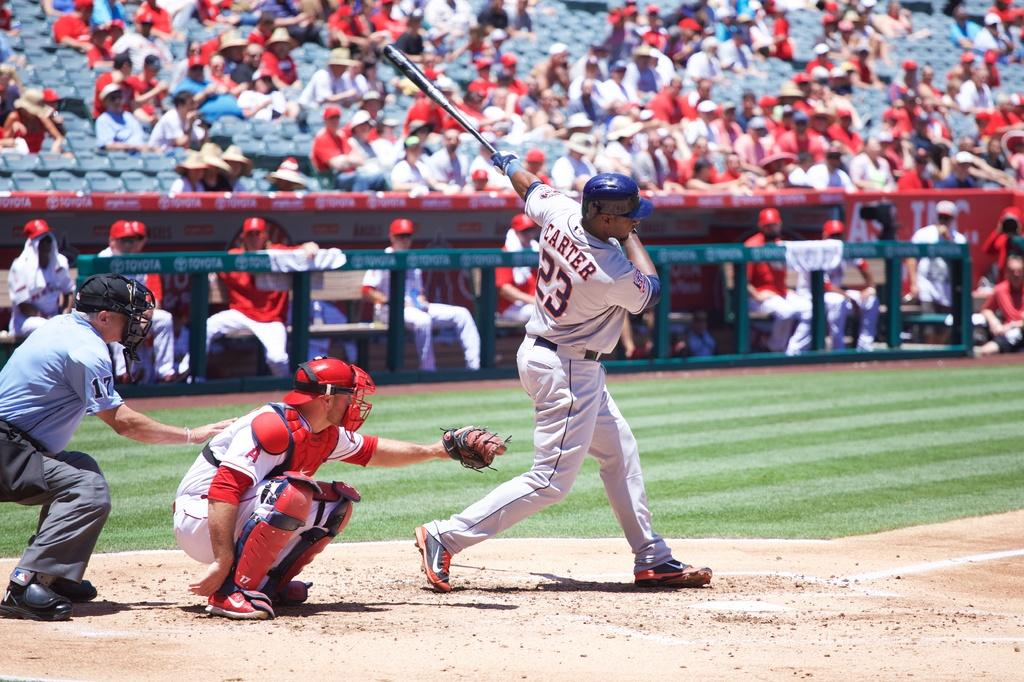Provide a one-sentence caption for the provided image. Carter takes a called strike while swinging a bat. 